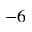<formula> <loc_0><loc_0><loc_500><loc_500>^ { - 6 }</formula> 